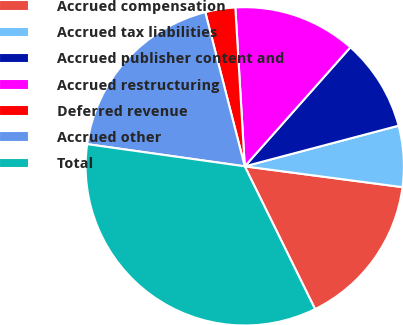Convert chart. <chart><loc_0><loc_0><loc_500><loc_500><pie_chart><fcel>Accrued compensation<fcel>Accrued tax liabilities<fcel>Accrued publisher content and<fcel>Accrued restructuring<fcel>Deferred revenue<fcel>Accrued other<fcel>Total<nl><fcel>15.63%<fcel>6.2%<fcel>9.34%<fcel>12.49%<fcel>3.05%<fcel>18.78%<fcel>34.51%<nl></chart> 